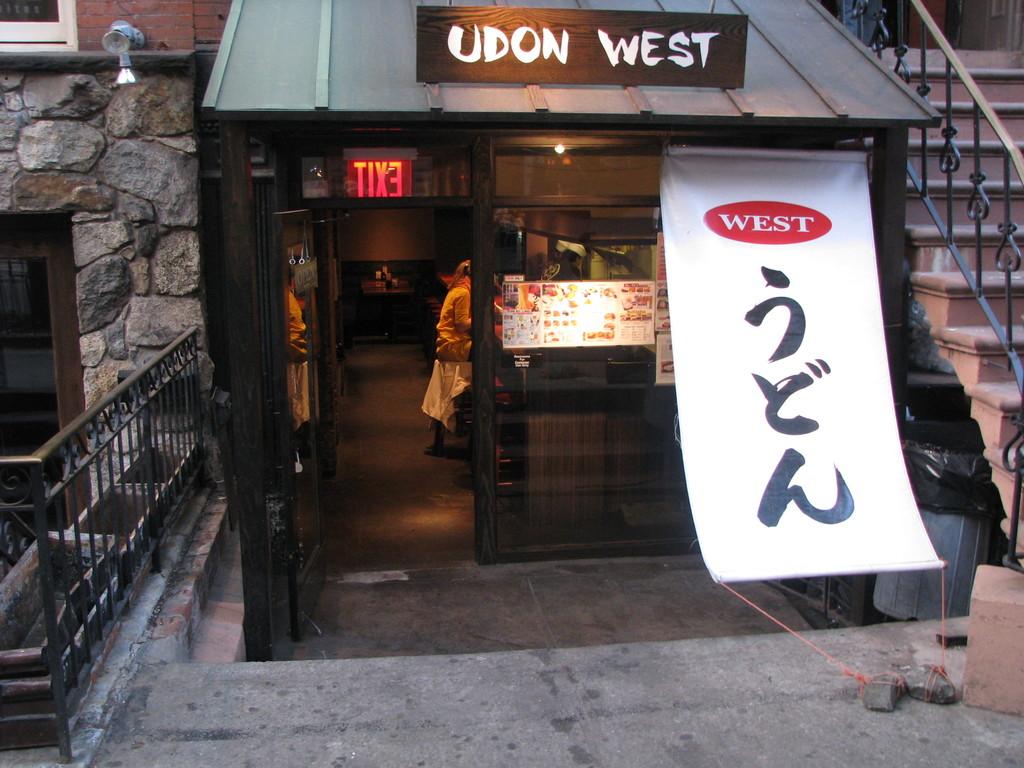What is the name of this business?
Ensure brevity in your answer.  Udon west. What does the sign say in glowing red letters?
Your answer should be compact. Exit. 